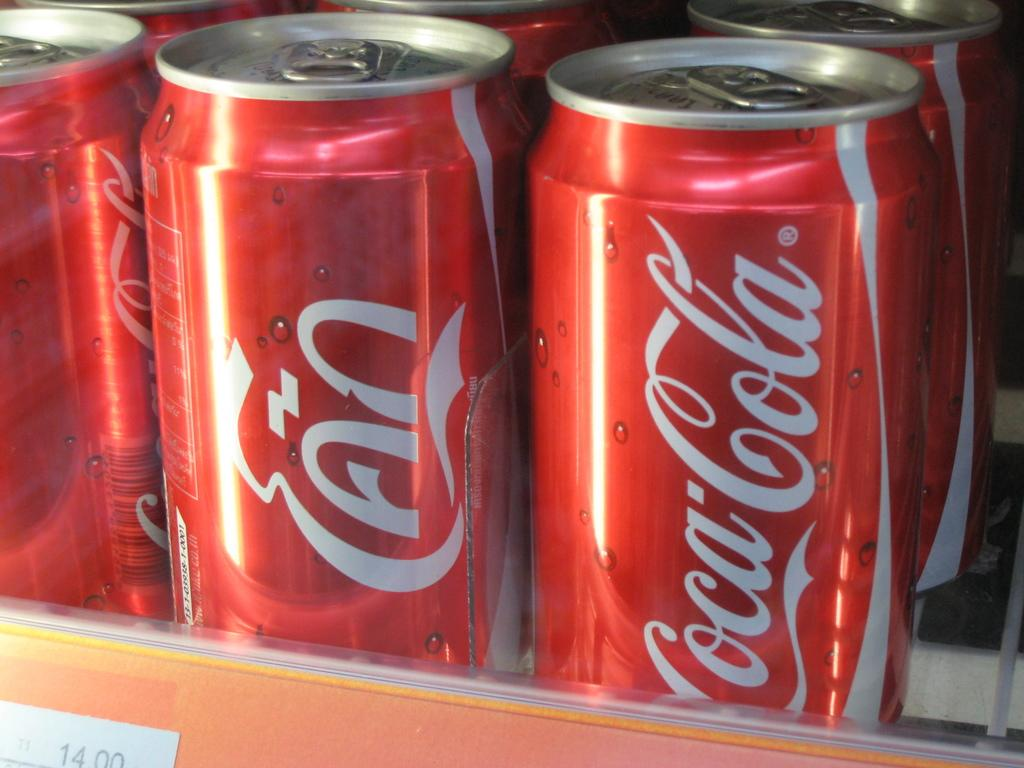<image>
Provide a brief description of the given image. A can of Coca-cola sits with several other red cans. 